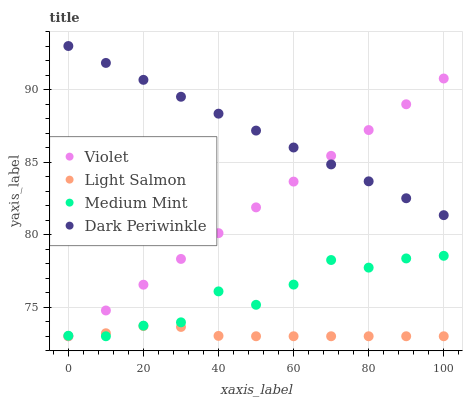Does Light Salmon have the minimum area under the curve?
Answer yes or no. Yes. Does Dark Periwinkle have the maximum area under the curve?
Answer yes or no. Yes. Does Dark Periwinkle have the minimum area under the curve?
Answer yes or no. No. Does Light Salmon have the maximum area under the curve?
Answer yes or no. No. Is Violet the smoothest?
Answer yes or no. Yes. Is Medium Mint the roughest?
Answer yes or no. Yes. Is Light Salmon the smoothest?
Answer yes or no. No. Is Light Salmon the roughest?
Answer yes or no. No. Does Medium Mint have the lowest value?
Answer yes or no. Yes. Does Dark Periwinkle have the lowest value?
Answer yes or no. No. Does Dark Periwinkle have the highest value?
Answer yes or no. Yes. Does Light Salmon have the highest value?
Answer yes or no. No. Is Medium Mint less than Dark Periwinkle?
Answer yes or no. Yes. Is Dark Periwinkle greater than Medium Mint?
Answer yes or no. Yes. Does Medium Mint intersect Violet?
Answer yes or no. Yes. Is Medium Mint less than Violet?
Answer yes or no. No. Is Medium Mint greater than Violet?
Answer yes or no. No. Does Medium Mint intersect Dark Periwinkle?
Answer yes or no. No. 